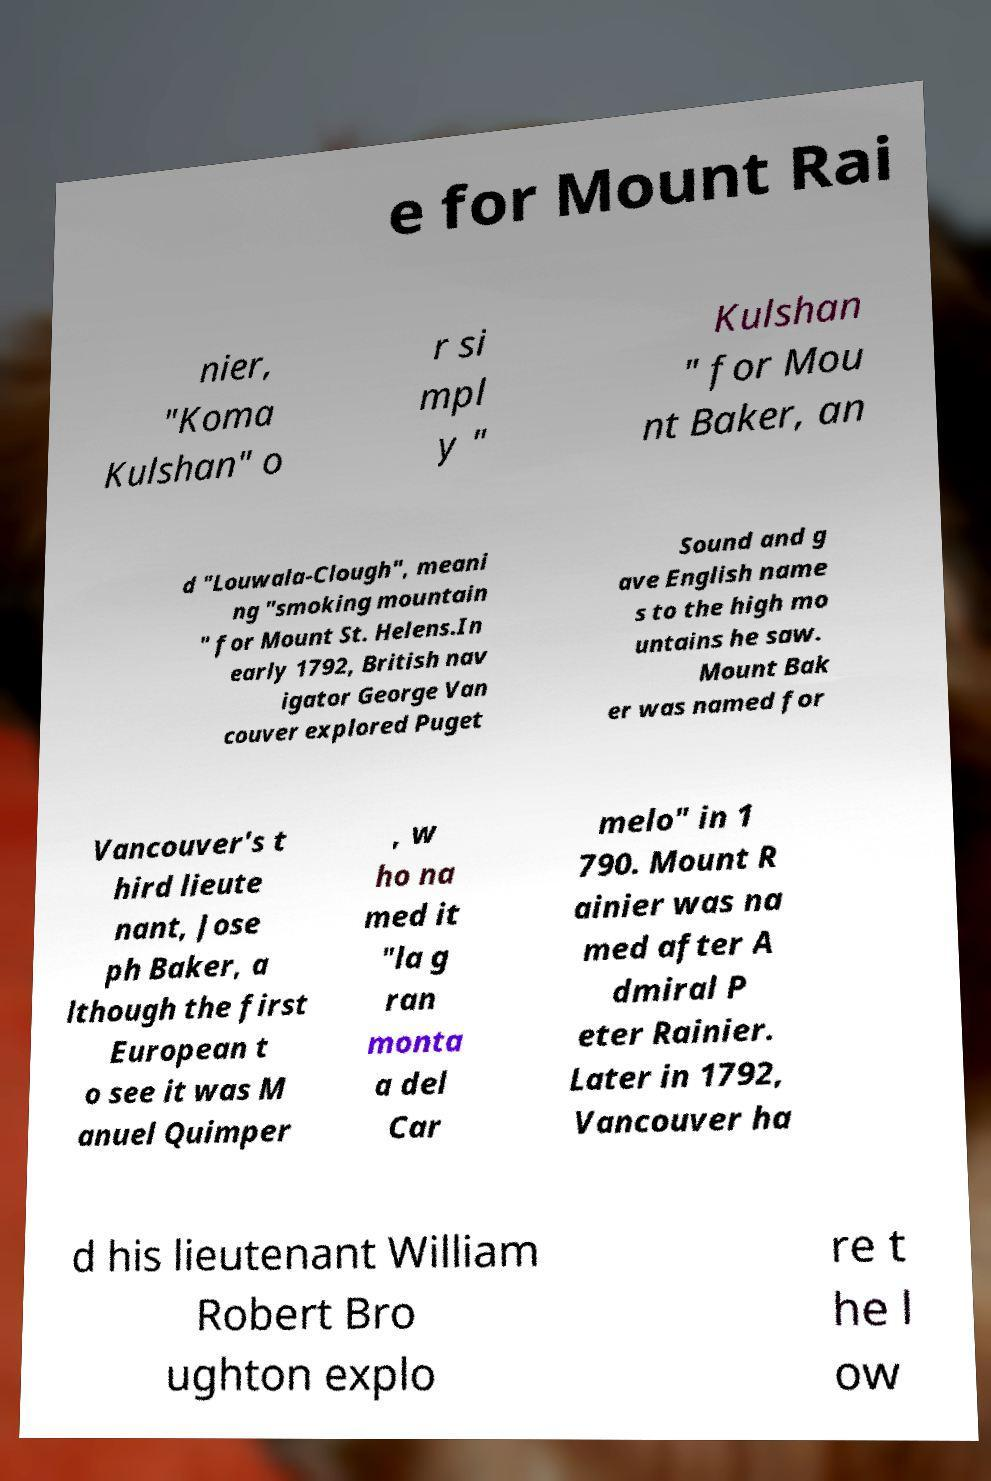What messages or text are displayed in this image? I need them in a readable, typed format. e for Mount Rai nier, "Koma Kulshan" o r si mpl y " Kulshan " for Mou nt Baker, an d "Louwala-Clough", meani ng "smoking mountain " for Mount St. Helens.In early 1792, British nav igator George Van couver explored Puget Sound and g ave English name s to the high mo untains he saw. Mount Bak er was named for Vancouver's t hird lieute nant, Jose ph Baker, a lthough the first European t o see it was M anuel Quimper , w ho na med it "la g ran monta a del Car melo" in 1 790. Mount R ainier was na med after A dmiral P eter Rainier. Later in 1792, Vancouver ha d his lieutenant William Robert Bro ughton explo re t he l ow 